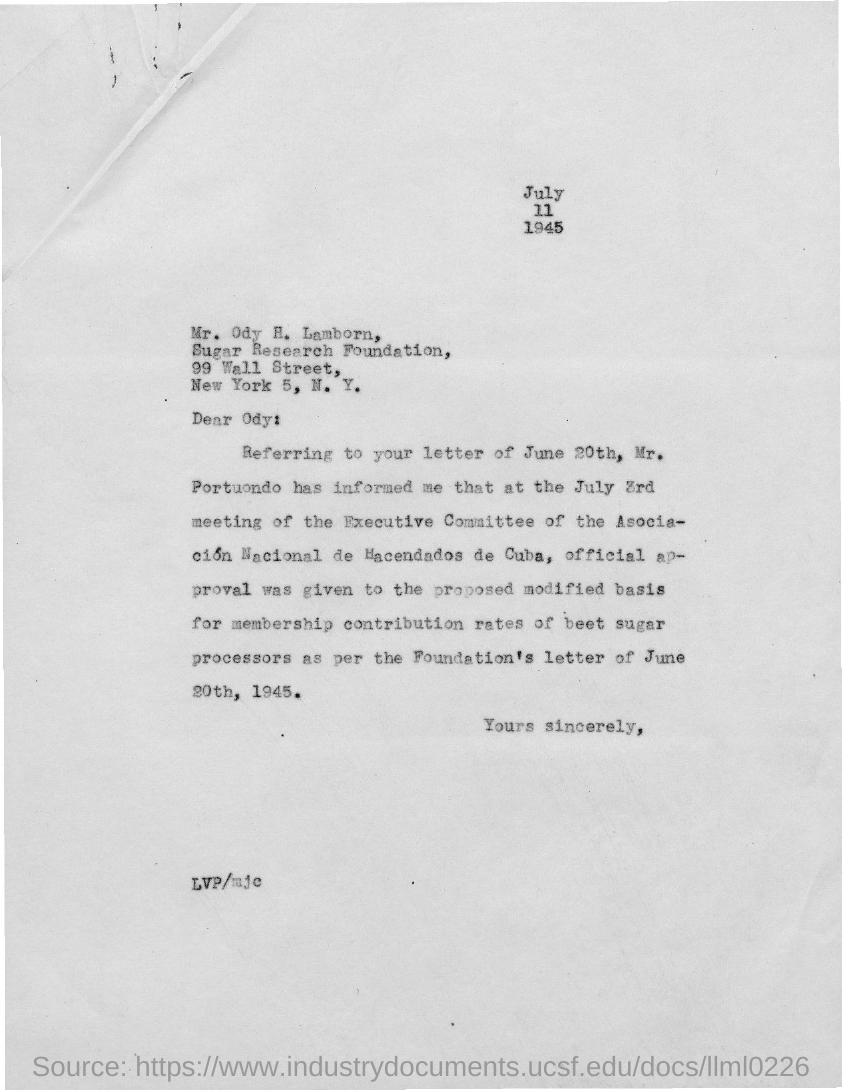What is the year mentioned in the given letter ?
Provide a succinct answer. 1945. What is the name of the foundation mentioned in the given letter ?
Your answer should be compact. Sugar Research foundation. What is the name of the street mentioned in the given letter ?
Offer a very short reply. 99 wall street. To whom this letter was written ?
Provide a succinct answer. Ody. 